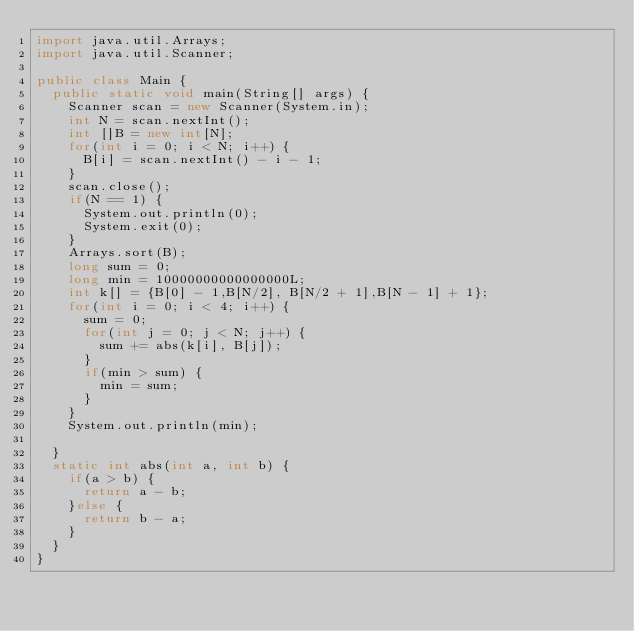Convert code to text. <code><loc_0><loc_0><loc_500><loc_500><_Java_>import java.util.Arrays;
import java.util.Scanner;

public class Main {
	public static void main(String[] args) {
		Scanner scan = new Scanner(System.in);
		int N = scan.nextInt();
		int []B = new int[N];
		for(int i = 0; i < N; i++) {
			B[i] = scan.nextInt() - i - 1;
		}
		scan.close();
		if(N == 1) {
			System.out.println(0);
			System.exit(0);
		}
		Arrays.sort(B);
		long sum = 0;
		long min = 10000000000000000L;
		int k[] = {B[0] - 1,B[N/2], B[N/2 + 1],B[N - 1] + 1};
		for(int i = 0; i < 4; i++) {
			sum = 0;
			for(int j = 0; j < N; j++) {
				sum += abs(k[i], B[j]);
			}
			if(min > sum) {
				min = sum;
			}
		}
		System.out.println(min);

	}
	static int abs(int a, int b) {
		if(a > b) {
			return a - b;
		}else {
			return b - a;
		}
	}
}</code> 